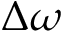<formula> <loc_0><loc_0><loc_500><loc_500>\Delta \omega</formula> 